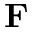<formula> <loc_0><loc_0><loc_500><loc_500>F</formula> 